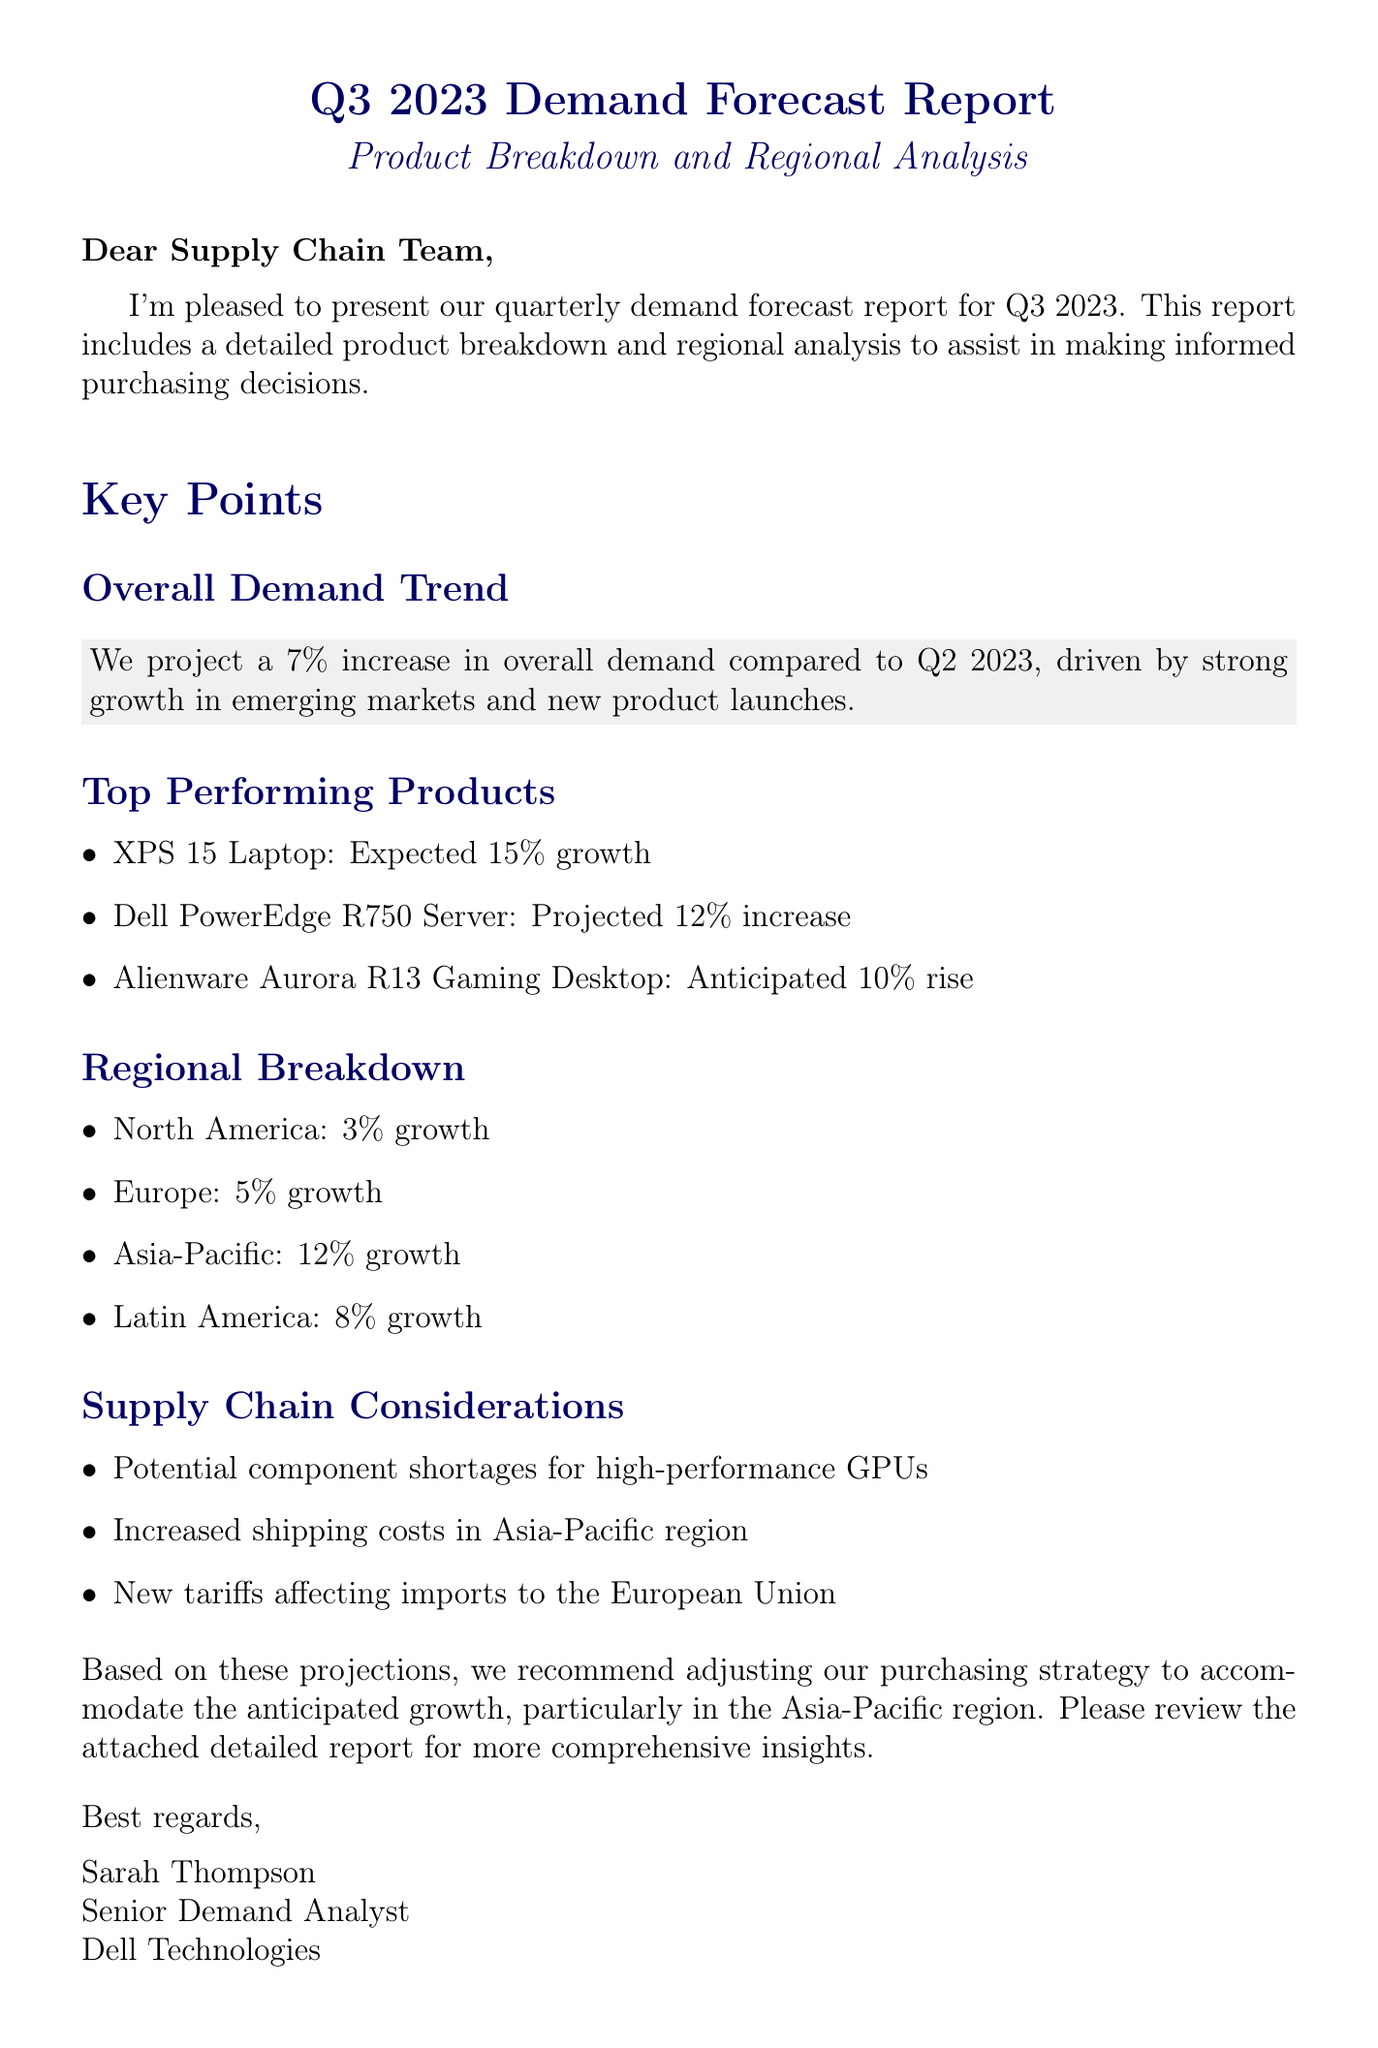What is the subject of the report? The subject of the report is stated in the title of the email.
Answer: Q3 2023 Demand Forecast Report - Product Breakdown and Regional Analysis What is the projected overall demand increase for Q3 2023? The overall demand trend provides this specific percentage increase.
Answer: 7% Which product is expected to have the highest growth? The top-performing products section lists their expected growth rates, highlighting which product has the highest.
Answer: XPS 15 Laptop What is the growth rate for the Asia-Pacific region? The regional breakdown section gives specific growth rates for each region, including Asia-Pacific.
Answer: 12% What significant supply chain issue is mentioned? The supply chain considerations section lists important issues affecting the supply chain.
Answer: Potential component shortages for high-performance GPUs What recommendation is made regarding purchasing strategy? The conclusion summarizes the suggested actions based on the report's findings regarding purchasing strategy.
Answer: Adjusting our purchasing strategy to accommodate the anticipated growth How many top-performing products are listed? The top-performing products section contains a specific number of products indicated.
Answer: 3 What is the projected growth rate for Latin America? The regional breakdown lists specific growth rates, providing the answer for Latin America.
Answer: 8% 